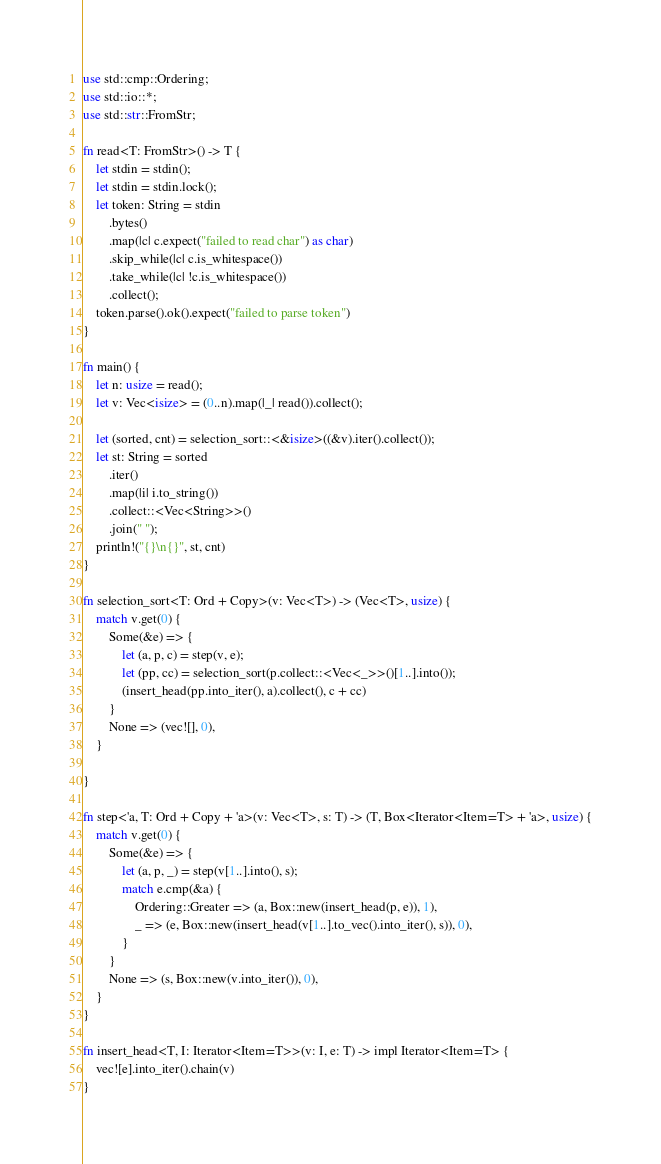Convert code to text. <code><loc_0><loc_0><loc_500><loc_500><_Rust_>use std::cmp::Ordering;
use std::io::*;
use std::str::FromStr;

fn read<T: FromStr>() -> T {
    let stdin = stdin();
    let stdin = stdin.lock();
    let token: String = stdin
        .bytes()
        .map(|c| c.expect("failed to read char") as char)
        .skip_while(|c| c.is_whitespace())
        .take_while(|c| !c.is_whitespace())
        .collect();
    token.parse().ok().expect("failed to parse token")
}

fn main() {
    let n: usize = read();
    let v: Vec<isize> = (0..n).map(|_| read()).collect();

    let (sorted, cnt) = selection_sort::<&isize>((&v).iter().collect());
    let st: String = sorted
        .iter()
        .map(|i| i.to_string())
        .collect::<Vec<String>>()
        .join(" ");
    println!("{}\n{}", st, cnt)
}

fn selection_sort<T: Ord + Copy>(v: Vec<T>) -> (Vec<T>, usize) {
    match v.get(0) {
        Some(&e) => {
            let (a, p, c) = step(v, e);
            let (pp, cc) = selection_sort(p.collect::<Vec<_>>()[1..].into());
            (insert_head(pp.into_iter(), a).collect(), c + cc)
        }
        None => (vec![], 0),
    }

}

fn step<'a, T: Ord + Copy + 'a>(v: Vec<T>, s: T) -> (T, Box<Iterator<Item=T> + 'a>, usize) {
    match v.get(0) {
        Some(&e) => {
            let (a, p, _) = step(v[1..].into(), s);
            match e.cmp(&a) {
                Ordering::Greater => (a, Box::new(insert_head(p, e)), 1),
                _ => (e, Box::new(insert_head(v[1..].to_vec().into_iter(), s)), 0),
            }
        }
        None => (s, Box::new(v.into_iter()), 0),
    }
}

fn insert_head<T, I: Iterator<Item=T>>(v: I, e: T) -> impl Iterator<Item=T> {
    vec![e].into_iter().chain(v)
}

</code> 